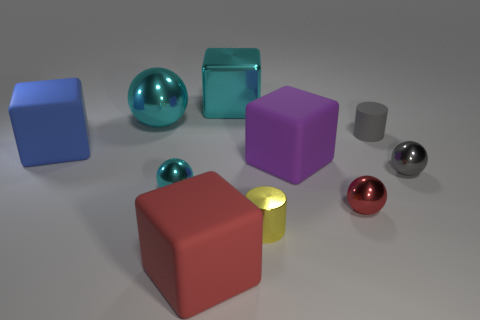Subtract 1 balls. How many balls are left? 3 Subtract all blue spheres. Subtract all red cylinders. How many spheres are left? 4 Subtract all cylinders. How many objects are left? 8 Subtract all yellow things. Subtract all red cylinders. How many objects are left? 9 Add 7 small gray metal things. How many small gray metal things are left? 8 Add 2 gray rubber things. How many gray rubber things exist? 3 Subtract 1 blue blocks. How many objects are left? 9 